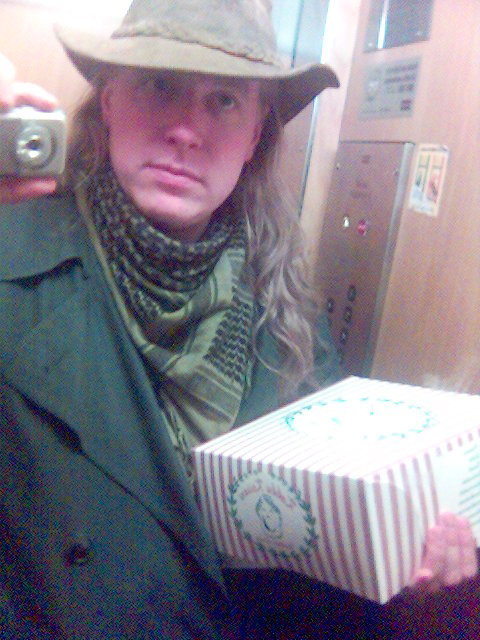<image>What brand is in the cardboard box? I am not sure about the brand in the cardboard box. It could be 'cupcakes', 'creme', 'krispy kreme', 'red stripe', 'durable' or 'tiffany'. What brand is in the cardboard box? I don't know what brand is in the cardboard box. It can be Krispy Kreme or something else. 